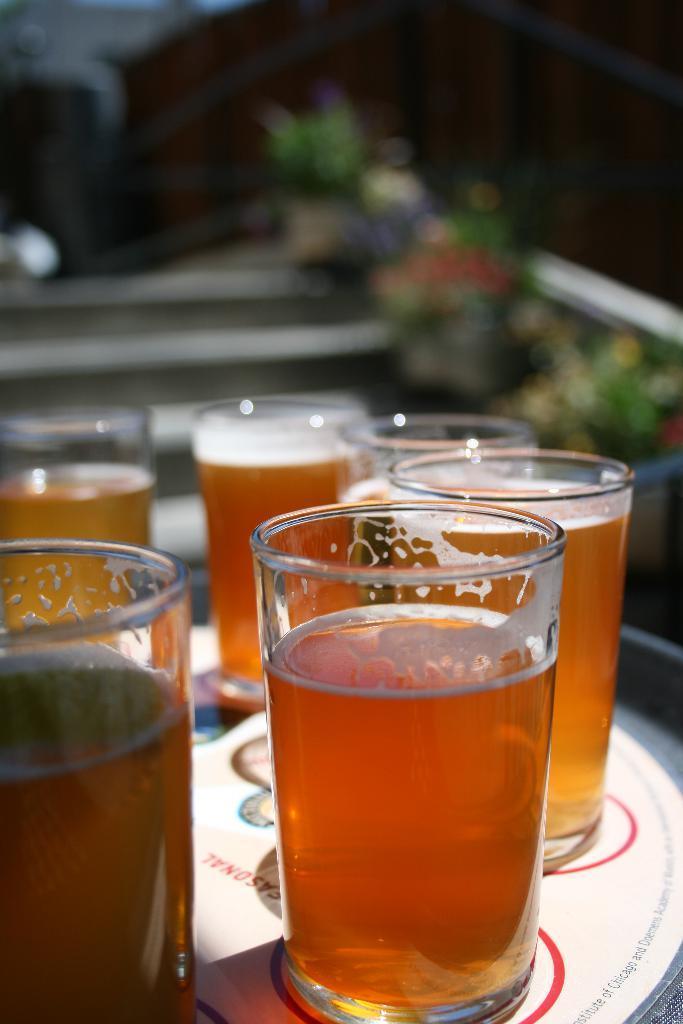How would you summarize this image in a sentence or two? In the foreground of the picture there are glasses filled with drinks, placed on a table. The background is blurred. 